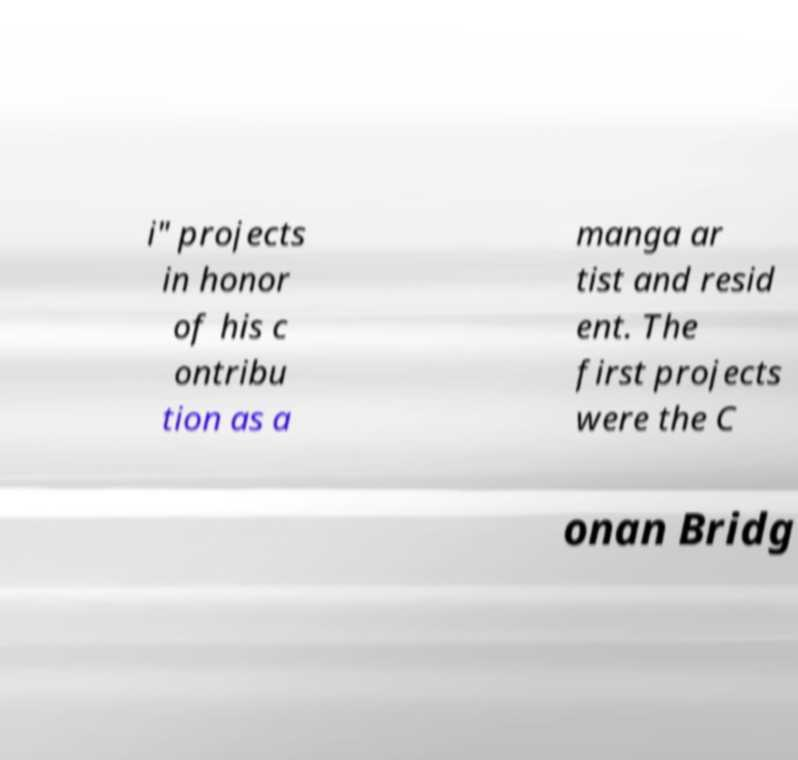For documentation purposes, I need the text within this image transcribed. Could you provide that? i" projects in honor of his c ontribu tion as a manga ar tist and resid ent. The first projects were the C onan Bridg 